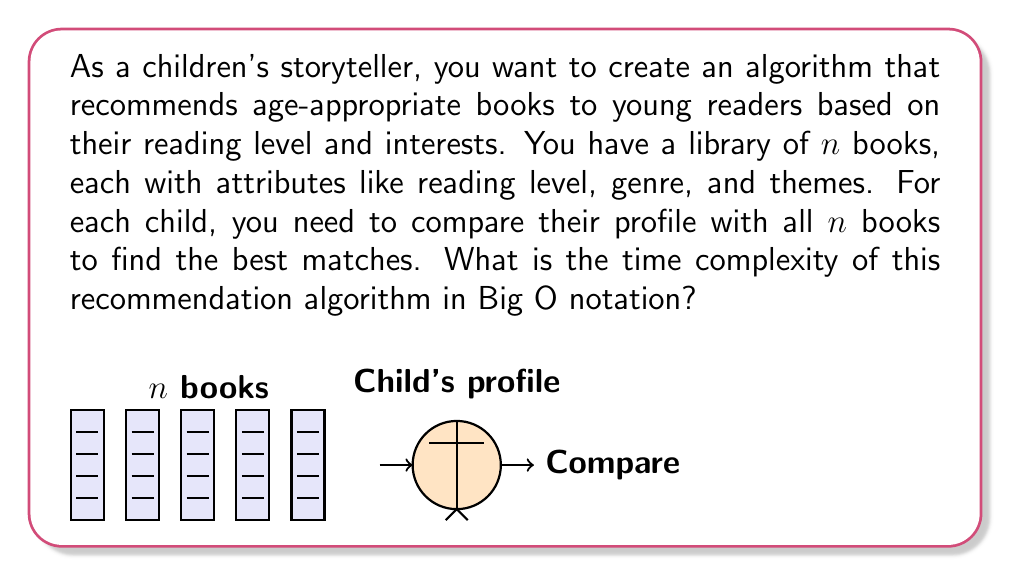Show me your answer to this math problem. Let's analyze the time complexity of this recommendation algorithm step by step:

1) For each child, we need to compare their profile with all $n$ books in the library.

2) The comparison process involves checking multiple attributes (e.g., reading level, genre, themes) for each book. Let's assume the number of attributes is constant, say $k$.

3) For each book, we perform $k$ comparisons with the child's profile. Since $k$ is constant, we can consider this as a single operation.

4) We repeat this comparison for all $n$ books in the library.

5) Therefore, for one child, we perform $n$ operations (each operation being the comparison of the child's profile with a book).

6) The number of operations is directly proportional to the number of books $n$.

7) In Big O notation, we express this as $O(n)$, which represents linear time complexity.

8) If we were to repeat this process for $m$ children, the time complexity would become $O(mn)$, but since the question asks about the algorithm for recommending books to each child, we focus on the complexity for a single child.

The linear time complexity $O(n)$ means that the time taken by the algorithm increases linearly with the number of books in the library. This is a reasonable complexity for a recommendation system, but for very large libraries, more efficient algorithms (like indexing or clustering) might be considered to improve performance.
Answer: $O(n)$ 